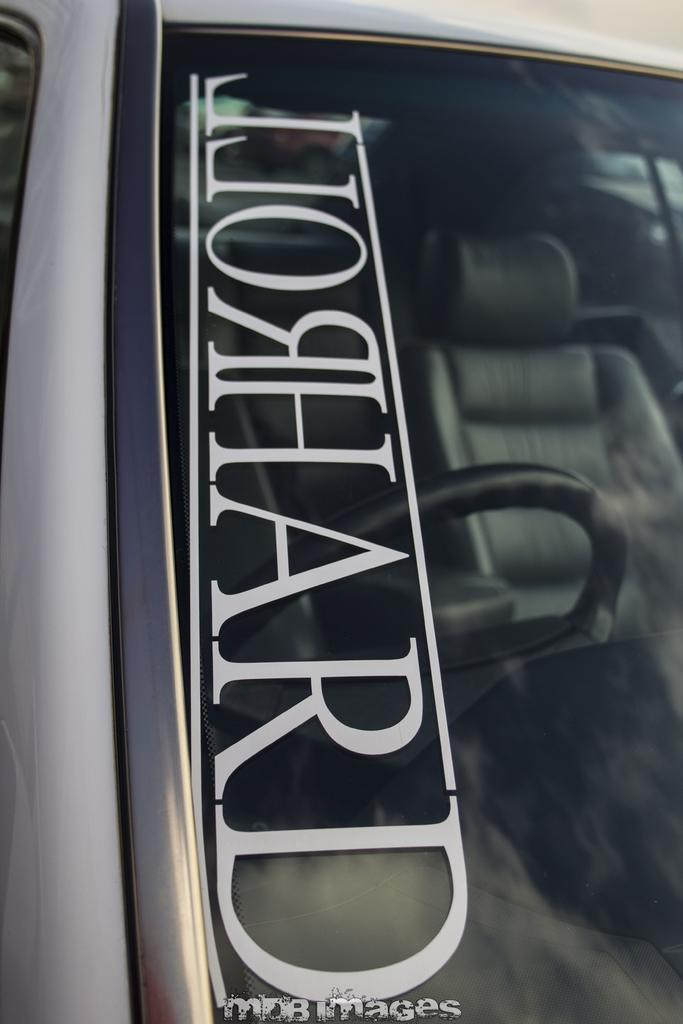What is the main subject of the image? The main subject of the image is the windshield of a car. What is written or displayed on the windshield? There is text on the windshield. What can be seen through the windshield? The steering wheel and seats are visible through the windshield. What time of day does the trouble occur in the image? There is no indication of trouble or a specific time of day in the image. The image only shows a car windshield with text and objects visible through it. 